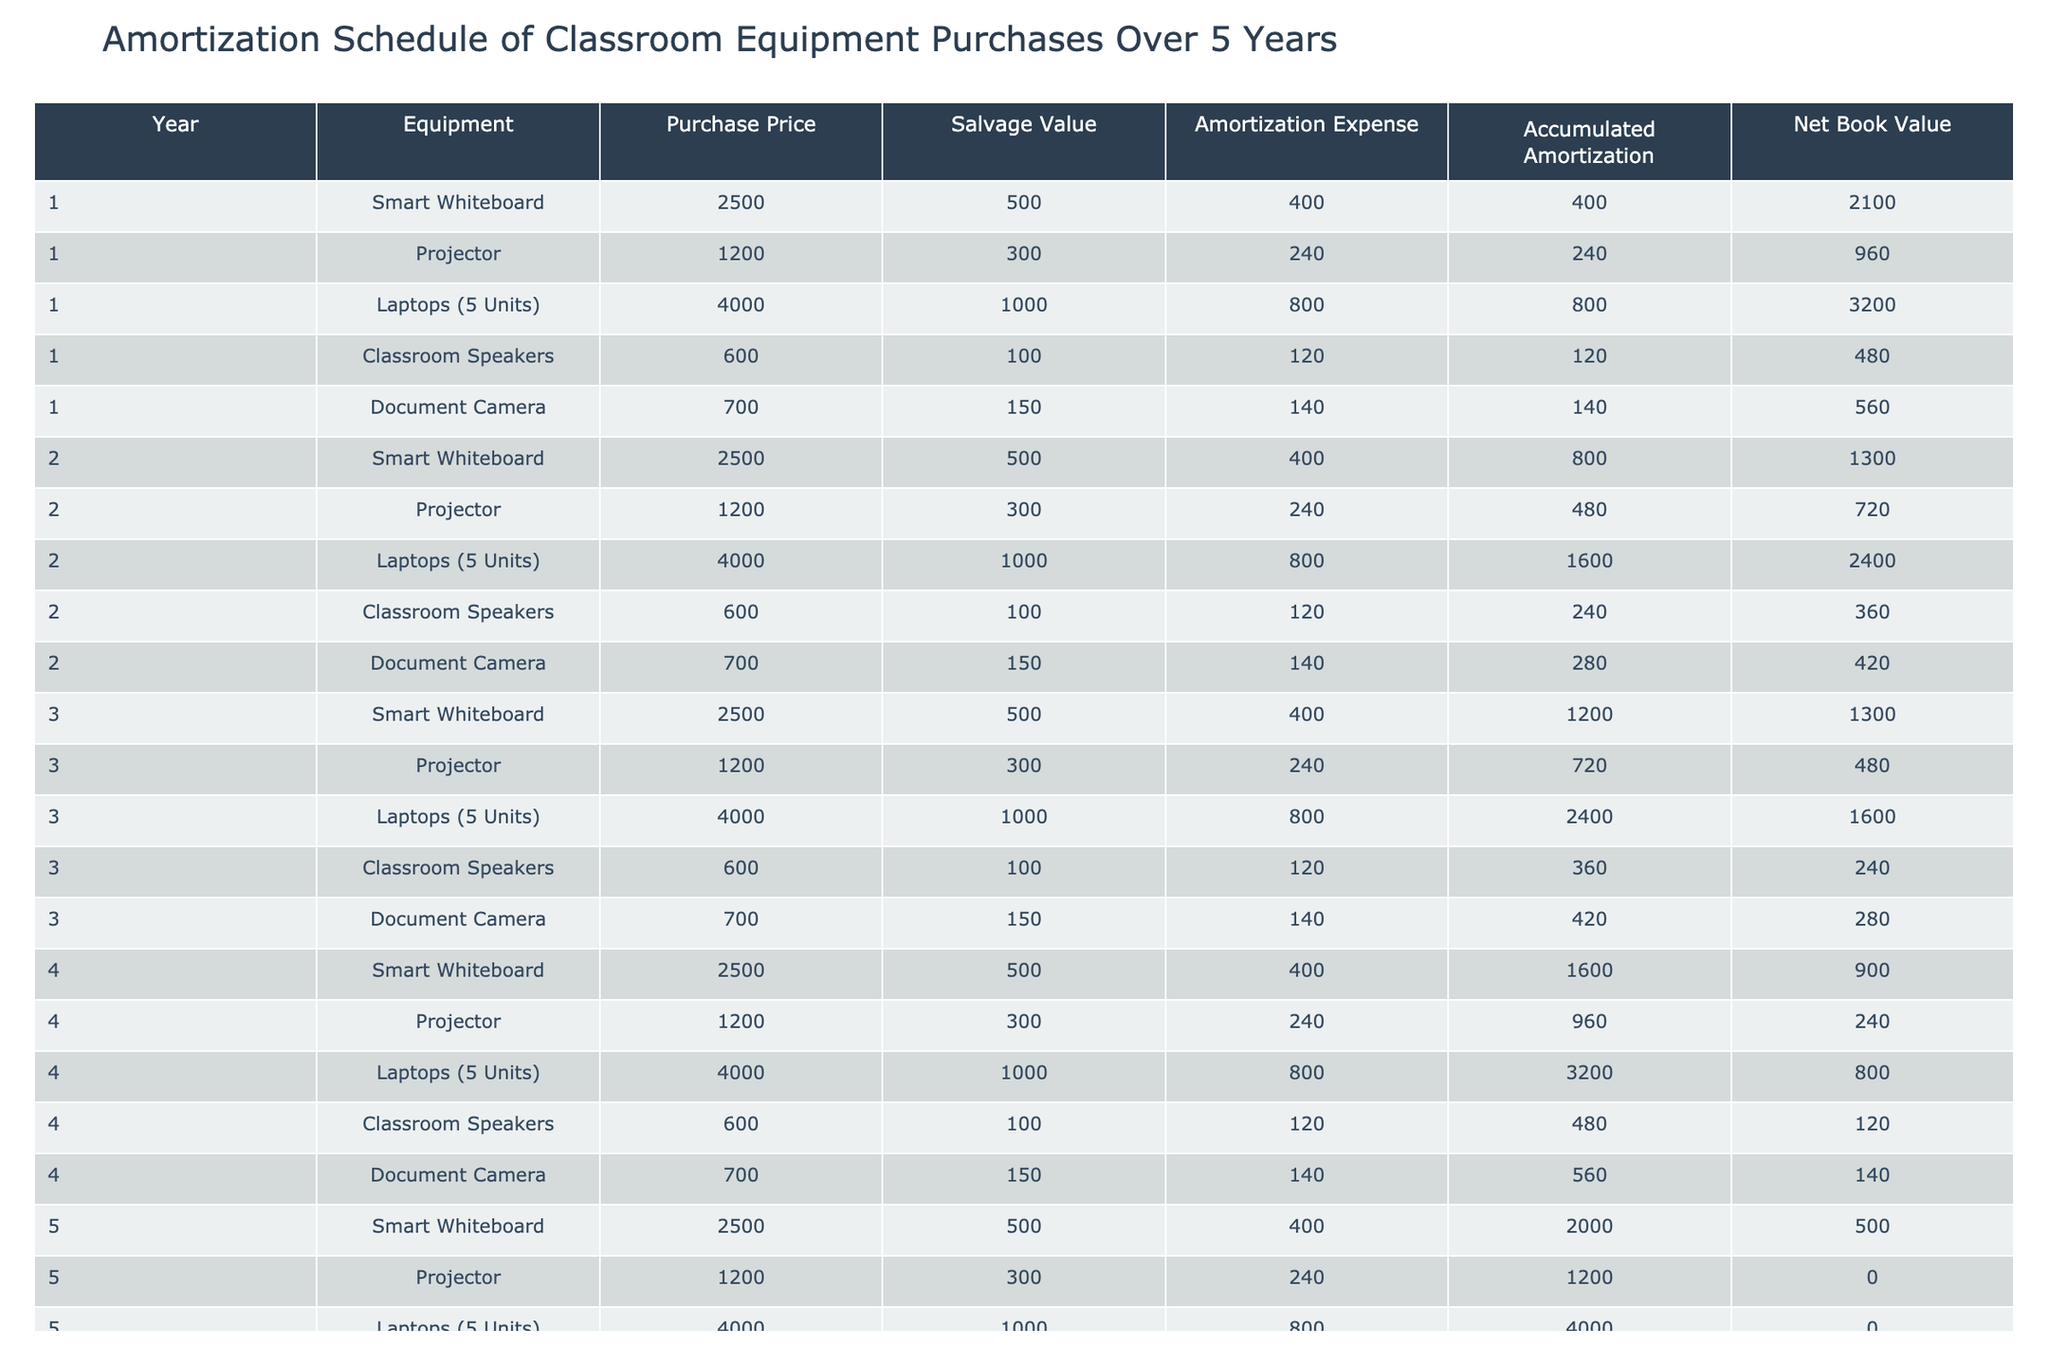What is the purchase price of the Smart Whiteboard? The purchase price of the Smart Whiteboard is provided directly in the table under the "Purchase Price" column for Year 1, which shows it as 2500.
Answer: 2500 What is the total amortization expense for Year 2? By looking at the table, the total amortization expense for Year 2 can be calculated by adding the expenses for all pieces of equipment: 400 (Smart Whiteboard) + 240 (Projector) + 800 (Laptops) + 120 (Classroom Speakers) + 140 (Document Camera) = 1700.
Answer: 1700 Is the net book value of the Projector zero in Year 5? The net book value for the Projector in Year 5 is listed in the table as 0, confirming that it is indeed zero.
Answer: Yes How much equipment has a net book value greater than 1000 in Year 3? First, we must look at the net book values in Year 3. The Smart Whiteboard (1300) and Laptops (1600) both exceed 1000. The total count hence is 2 pieces of equipment.
Answer: 2 What is the average accumulated amortization for Year 4 across all equipment? To find the average, we need to sum the accumulated amortization values for Year 4: 1600 (Smart Whiteboard) + 960 (Projector) + 3200 (Laptops) + 480 (Classroom Speakers) + 560 (Document Camera) = 5880. Then divide by the number of equipment, which is 5. So, 5880 / 5 = 1176.
Answer: 1176 How does the salvage value of the Laptops compare with that of the Classroom Speakers? The salvage value for the Laptops is 1000, while that for the Classroom Speakers is 100. Clearly, 1000 is significantly greater than 100, indicating a larger salvage value for the Laptops.
Answer: Laptops have a higher salvage value What is the total accumulated amortization for the Classroom Speakers by Year 5? By summing the accumulated amortization across the years for Classroom Speakers: 120 (Year 1) + 240 (Year 2) + 360 (Year 3) + 480 (Year 4) + 600 (Year 5) = 1800.
Answer: 1800 Is it true that all equipment has a positive net book value at the end of Year 1? The net book values listed at the end of Year 1 are 2100 (Smart Whiteboard), 960 (Projector), 3200 (Laptops), 480 (Classroom Speakers), and 560 (Document Camera). Since all values are positive, the statement is true.
Answer: Yes Which equipment had the highest amortization expense in Year 4? From the table, the amortization expenses for Year 4 are: 400 (Smart Whiteboard), 240 (Projector), 800 (Laptops), 120 (Classroom Speakers), and 140 (Document Camera). The highest amongst these is 800 for the Laptops.
Answer: Laptops 